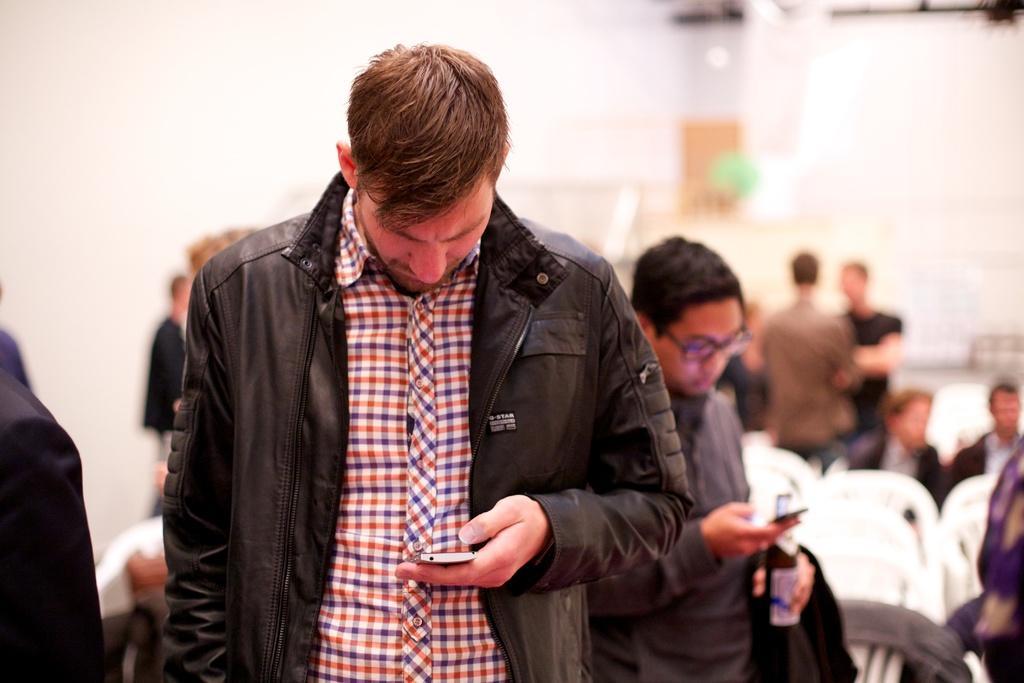Describe this image in one or two sentences. In this image we can see there are few persons standing and holding a phone and a bottle and a few persons are sitting on the chair. And at the back it looks like a blur. 